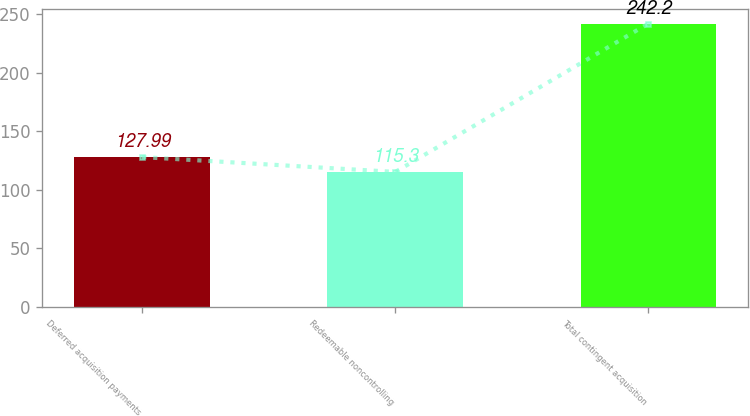Convert chart. <chart><loc_0><loc_0><loc_500><loc_500><bar_chart><fcel>Deferred acquisition payments<fcel>Redeemable noncontrolling<fcel>Total contingent acquisition<nl><fcel>127.99<fcel>115.3<fcel>242.2<nl></chart> 